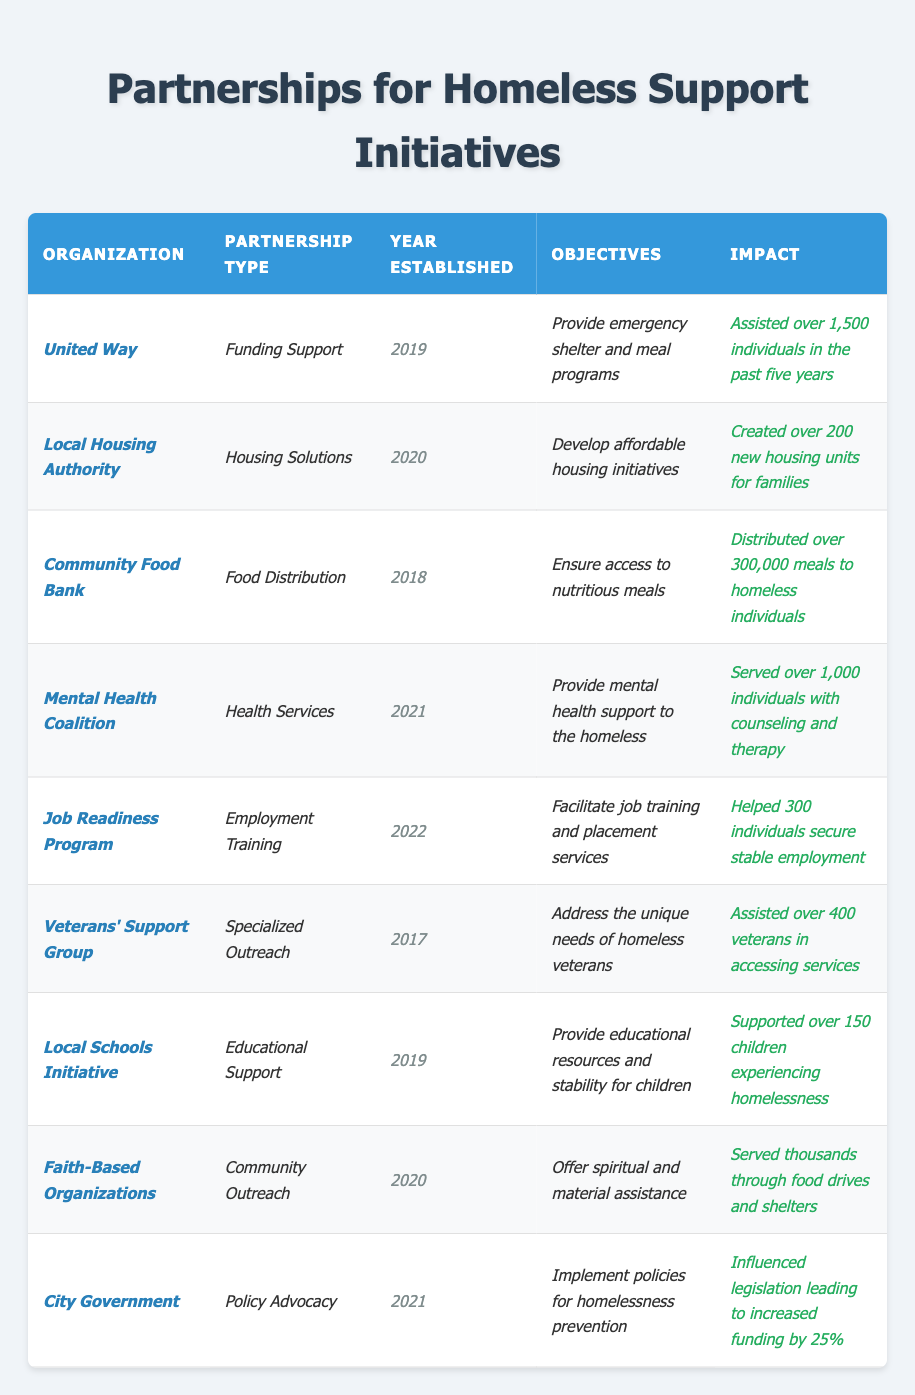What is the impact of the Community Food Bank? The table states that the Community Food Bank has distributed over 300,000 meals to homeless individuals.
Answer: Over 300,000 meals Which organization was established first? By comparing the "Year Established" column, the Veterans' Support Group was established in 2017, which is earlier than any other listed organization.
Answer: Veterans' Support Group How many housing units were created by the Local Housing Authority? The Local Housing Authority created over 200 new housing units for families, as stated in the "Impact" column.
Answer: Over 200 units Did the City Government influence funding? Yes, the table indicates that the City Government influenced legislation leading to increased funding by 25%.
Answer: Yes Which organization served the most individuals in the past five years? The United Way has assisted over 1,500 individuals, which is the highest number among all organizations listed.
Answer: United Way What is the total number of individuals served by the Mental Health Coalition and Job Readiness Program combined? The Mental Health Coalition served over 1,000 individuals, and the Job Readiness Program helped 300 individuals. Summing these gives 1,000 + 300 = 1,300 individuals served.
Answer: 1,300 individuals Are all organizations focused solely on one type of support? No, the organizations have diverse focuses, including food distribution, housing, health services, education, and employment training.
Answer: No Which partnership type has the most recent establishment year? The Job Readiness Program was established in 2022, which is the most recent year of establishment listed for any organization.
Answer: Employment Training How many initiatives mentioned provide mental health support? Only one organization, the Mental Health Coalition, explicitly focuses on providing mental health support to the homeless.
Answer: One initiative What percentage increase in funding did the City Government influence? The table states that the City Government influenced legislation leading to an increased funding by 25%.
Answer: 25% 